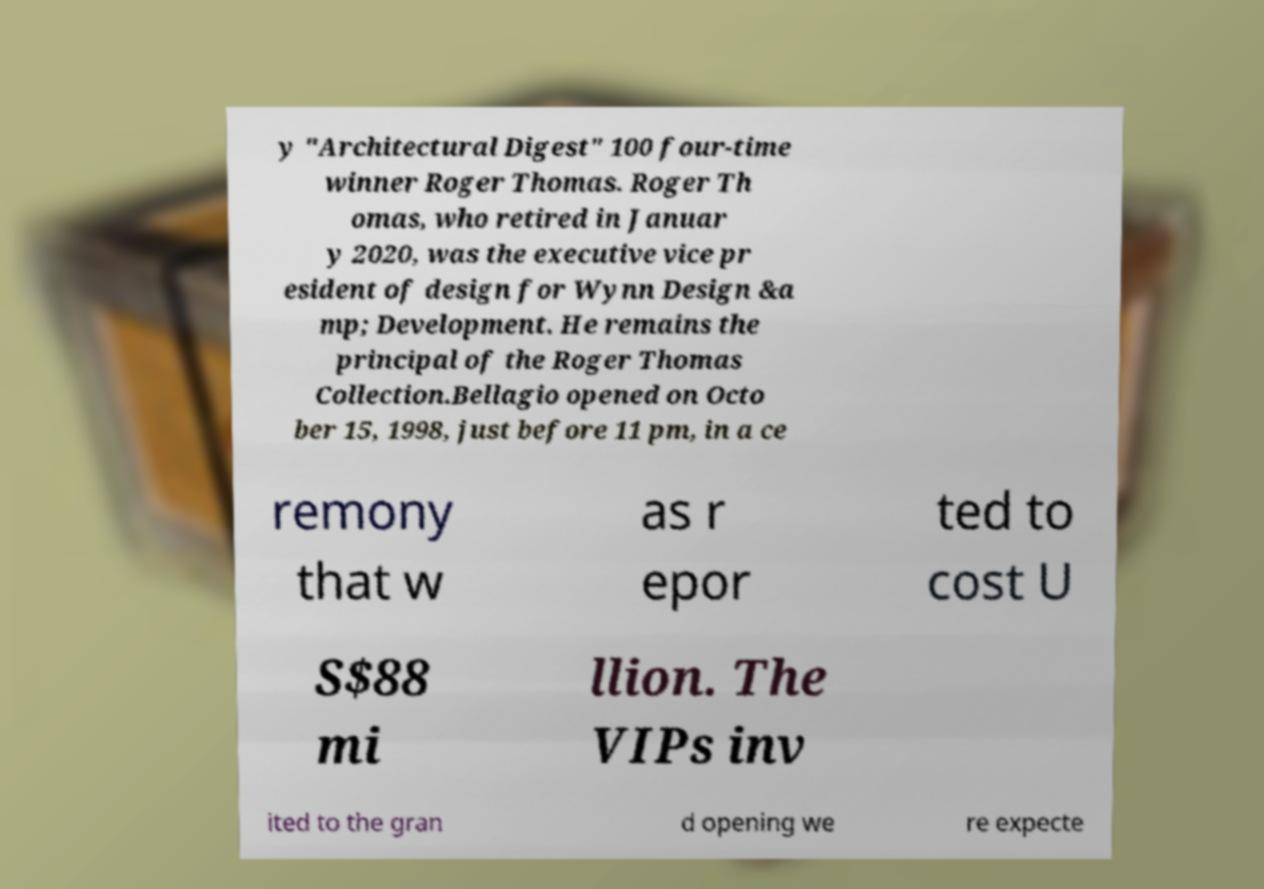There's text embedded in this image that I need extracted. Can you transcribe it verbatim? y "Architectural Digest" 100 four-time winner Roger Thomas. Roger Th omas, who retired in Januar y 2020, was the executive vice pr esident of design for Wynn Design &a mp; Development. He remains the principal of the Roger Thomas Collection.Bellagio opened on Octo ber 15, 1998, just before 11 pm, in a ce remony that w as r epor ted to cost U S$88 mi llion. The VIPs inv ited to the gran d opening we re expecte 